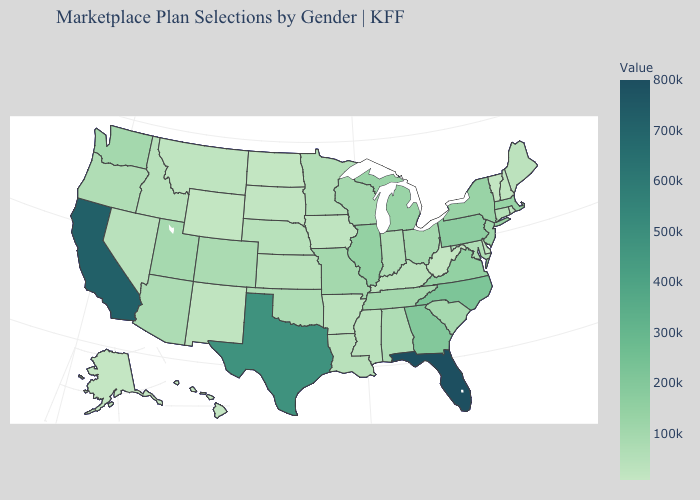Which states have the highest value in the USA?
Keep it brief. Florida. Does Tennessee have the highest value in the South?
Give a very brief answer. No. Which states have the lowest value in the Northeast?
Write a very short answer. Vermont. Among the states that border Arkansas , does Mississippi have the lowest value?
Quick response, please. Yes. Among the states that border Delaware , which have the lowest value?
Short answer required. Maryland. Does Alabama have the highest value in the South?
Give a very brief answer. No. 